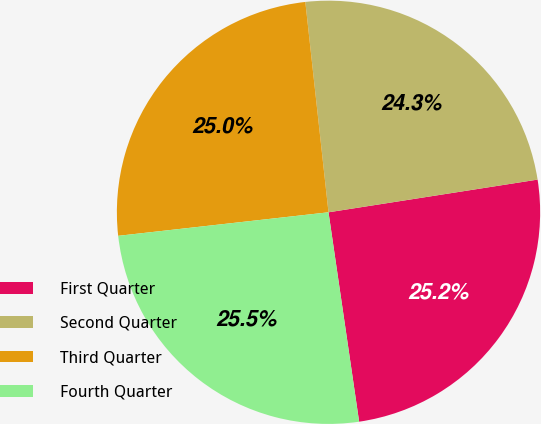Convert chart to OTSL. <chart><loc_0><loc_0><loc_500><loc_500><pie_chart><fcel>First Quarter<fcel>Second Quarter<fcel>Third Quarter<fcel>Fourth Quarter<nl><fcel>25.16%<fcel>24.28%<fcel>25.03%<fcel>25.54%<nl></chart> 